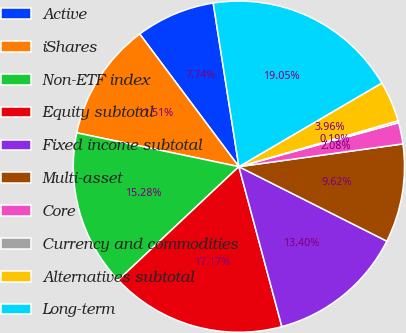Convert chart. <chart><loc_0><loc_0><loc_500><loc_500><pie_chart><fcel>Active<fcel>iShares<fcel>Non-ETF index<fcel>Equity subtotal<fcel>Fixed income subtotal<fcel>Multi-asset<fcel>Core<fcel>Currency and commodities<fcel>Alternatives subtotal<fcel>Long-term<nl><fcel>7.74%<fcel>11.51%<fcel>15.28%<fcel>17.17%<fcel>13.4%<fcel>9.62%<fcel>2.08%<fcel>0.19%<fcel>3.96%<fcel>19.05%<nl></chart> 